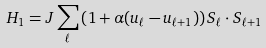<formula> <loc_0><loc_0><loc_500><loc_500>H _ { 1 } = J \sum _ { \ell } \left ( 1 + \alpha ( u _ { \ell } - u _ { \ell + 1 } ) \right ) { S } _ { \ell } \cdot { S } _ { \ell + 1 }</formula> 